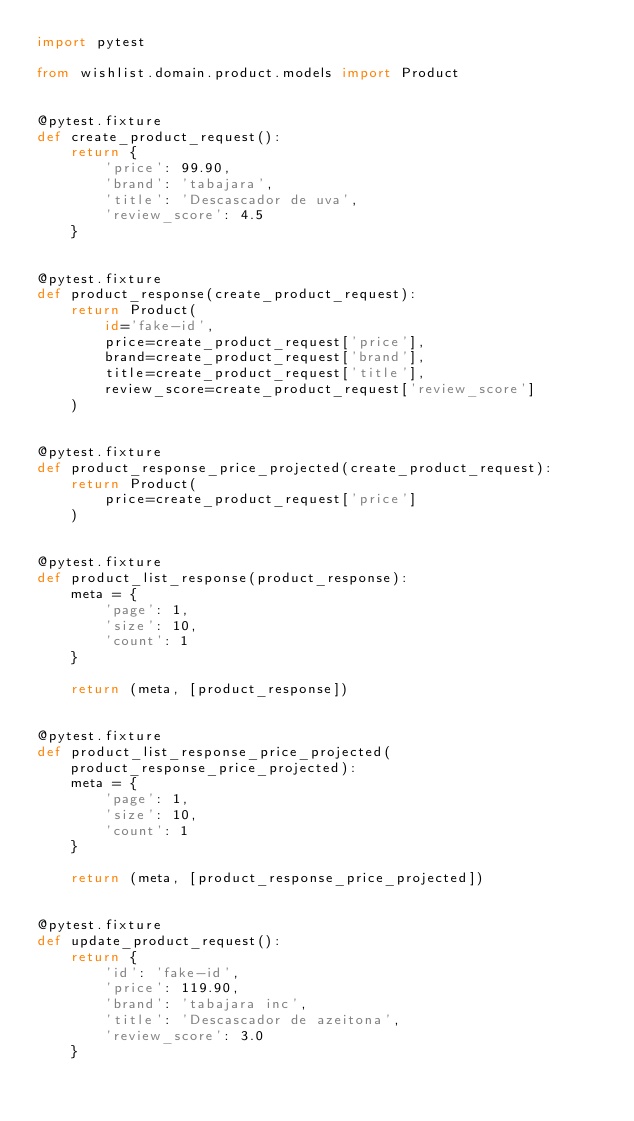<code> <loc_0><loc_0><loc_500><loc_500><_Python_>import pytest

from wishlist.domain.product.models import Product


@pytest.fixture
def create_product_request():
    return {
        'price': 99.90,
        'brand': 'tabajara',
        'title': 'Descascador de uva',
        'review_score': 4.5
    }


@pytest.fixture
def product_response(create_product_request):
    return Product(
        id='fake-id',
        price=create_product_request['price'],
        brand=create_product_request['brand'],
        title=create_product_request['title'],
        review_score=create_product_request['review_score']
    )


@pytest.fixture
def product_response_price_projected(create_product_request):
    return Product(
        price=create_product_request['price']
    )


@pytest.fixture
def product_list_response(product_response):
    meta = {
        'page': 1,
        'size': 10,
        'count': 1
    }

    return (meta, [product_response])


@pytest.fixture
def product_list_response_price_projected(product_response_price_projected):
    meta = {
        'page': 1,
        'size': 10,
        'count': 1
    }

    return (meta, [product_response_price_projected])


@pytest.fixture
def update_product_request():
    return {
        'id': 'fake-id',
        'price': 119.90,
        'brand': 'tabajara inc',
        'title': 'Descascador de azeitona',
        'review_score': 3.0
    }
</code> 